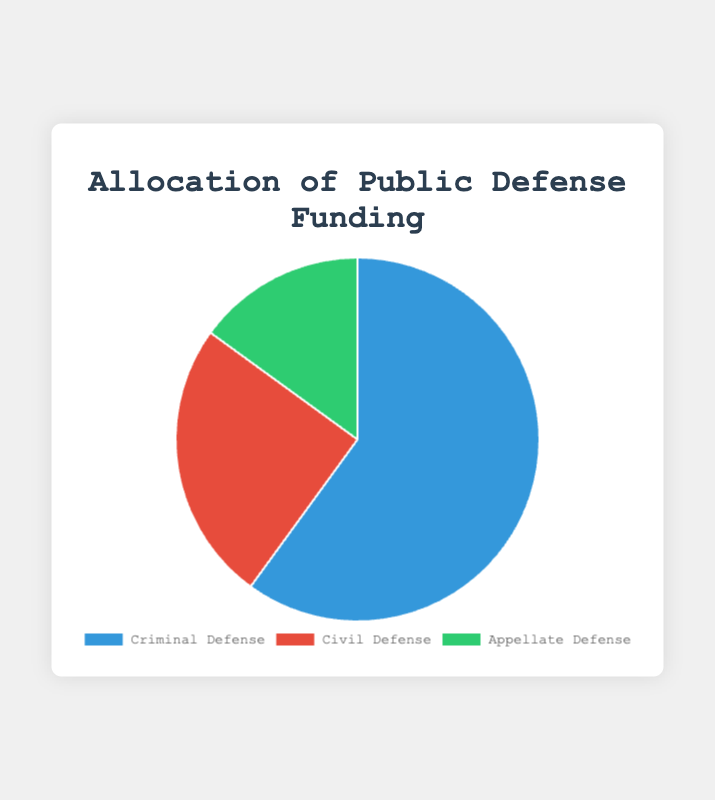What percentage of funding is allocated to criminal defense? Referring to the pie chart, the segment labeled 'Criminal Defense' corresponds to 60% of the total public defense funding.
Answer: 60% Which case type has the smallest allocation of funding? Referring to the pie chart, the segment labeled 'Appellate Defense' is the smallest, corresponding to 15% of the total funding.
Answer: Appellate Defense How much more funding does criminal defense receive compared to civil defense? The criminal defense allocation is 60%, and the civil defense allocation is 25%. Subtracting the latter from the former: 60% - 25% = 35%.
Answer: 35% What is the combined percentage allocation for civil and appellate defense? Sum the allocation percentages for civil defense (25%) and appellate defense (15%): 25% + 15% = 40%.
Answer: 40% Which segment is represented by the largest portion of the pie chart? Referring to the visual sizes in the pie chart, the largest segment represents 'Criminal Defense', which corresponds to 60% of the allocation.
Answer: Criminal Defense If the total budget is $1,000,000, how much funding goes to appellate defense? The appellate defense allocation percentage is 15%. Calculating the funding: 15/100 * $1,000,000 = $150,000.
Answer: $150,000 Is the funding for civil defense greater than that for appellate defense? Referring to the pie chart, the civil defense allocation is 25%, while the appellate defense allocation is 15%. Comparing these values, 25% is greater than 15%.
Answer: Yes What's the average percentage allocation for all three case types? The allocation percentages are 60%, 25%, and 15%. Adding them: 60 + 25 + 15 = 100. Dividing by the number of case types: 100 / 3 ≈ 33.33%.
Answer: ≈ 33.33% If an extra 5% of the total budget is reallocated to appellate defense from criminal defense, what would be the new allocations for both? Initially, criminal defense is 60% and appellate defense is 15%. Reallocating 5% reduces criminal defense to 55% and increases appellate defense to 20%.
Answer: Criminal: 55%, Appellate: 20% What is the visual color associated with civil defense in the chart? Referring to the pie chart, the segment labeled 'Civil Defense' is colored red.
Answer: Red 